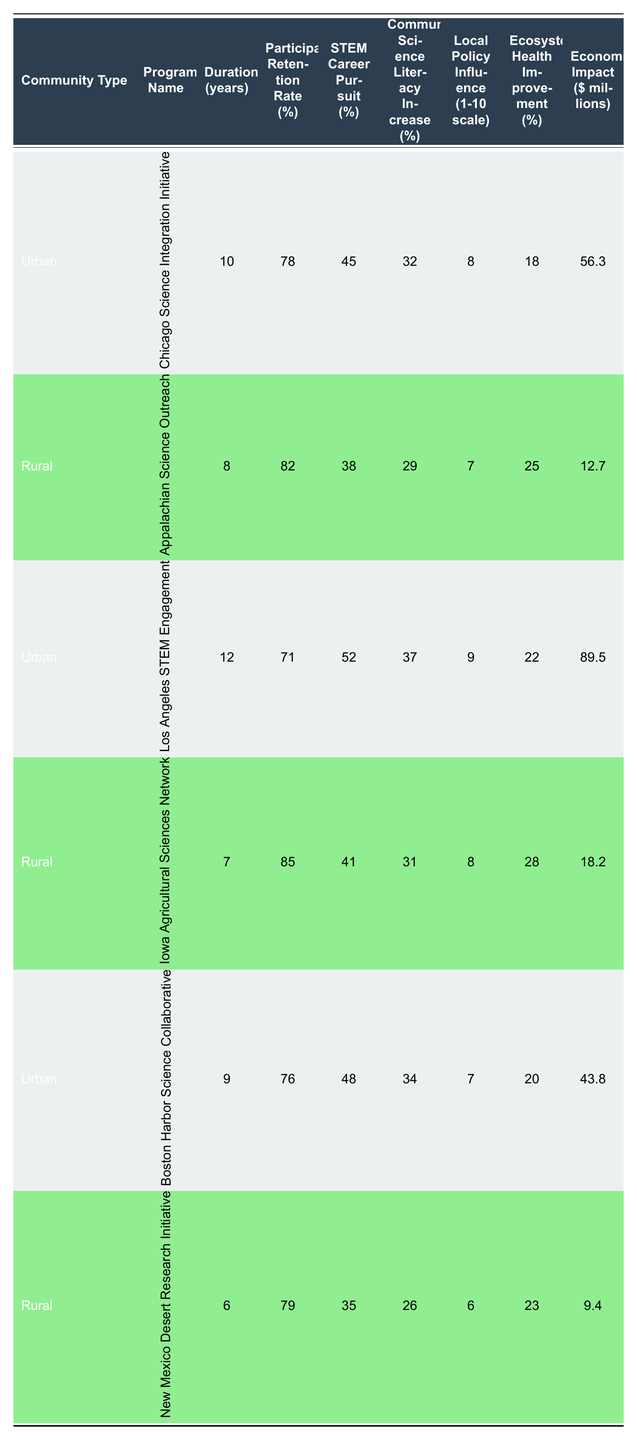What is the highest participant retention rate among the programs? The participant retention rates from the table are as follows: 78, 82, 71, 85, 76, and 79. The highest value is 85, which belongs to the 'Iowa Agricultural Sciences Network' program.
Answer: 85 Which urban program had the longest duration? The durations for urban programs are: 'Chicago Science Integration Initiative' - 10 years, 'Los Angeles STEM Engagement' - 12 years, and 'Boston Harbor Science Collaborative' - 9 years. The longest duration is 12 years for 'Los Angeles STEM Engagement'.
Answer: 12 Is there a rural program with a STEM career pursuit percentage above 40%? The rural programs show STEM career pursuit percentages of 38, 41, and 35. Only the 'Iowa Agricultural Sciences Network' has a STEM career pursuit percentage above 40%, which is 41%.
Answer: Yes What is the average economic impact of the urban programs? The economic impacts for urban programs are: 56.3, 89.5, and 43.8 million dollars. Summing them gives 189.6 million dollars. There are 3 programs, so the average is 189.6/3 = 63.2 million dollars.
Answer: 63.2 Which program had the highest local policy influence score? Evaluating the local policy influence scores: 'Chicago Science Integration Initiative' - 8, 'Los Angeles STEM Engagement' - 9, 'Boston Harbor Science Collaborative' - 7, 'Appalachian Science Outreach' - 7, 'Iowa Agricultural Sciences Network' - 8, 'New Mexico Desert Research Initiative' - 6. Thus, 'Los Angeles STEM Engagement' has the highest score of 9.
Answer: 9 What is the difference in community science literacy increase between the urban and rural programs? For urban programs, the science literacy increases are 32, 37, and 34%, averaging to (32 + 37 + 34)/3 = 34.33%. For rural programs, the increases are 29, 31, and 26%, averaging to (29 + 31 + 26)/3 = 28.67%. The difference is 34.33 - 28.67 = 5.66%.
Answer: 5.66 How many years of duration are needed on average across all programs? The durations of all programs are 10, 8, 12, 7, 9, and 6 years. Summing these gives 52 years, and the average is 52/6 = 8.67 years.
Answer: 8.67 Do the urban programs collectively show a higher ecosystem health improvement than the rural programs? The ecosystem health improvements for urban programs are 18, 22, and 20%, totaling 60% or an average of 20%. For rural programs: 25, 28, and 23%, totaling 76% or an average of 25.33%. Since 25.33% is higher than 20%, rural programs have higher collective ecosystem health improvement.
Answer: No 